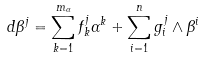<formula> <loc_0><loc_0><loc_500><loc_500>d \beta ^ { j } = \sum ^ { m _ { \alpha } } _ { k = 1 } f _ { k } ^ { j } \alpha ^ { k } + \sum ^ { n } _ { i = 1 } g ^ { j } _ { i } \land \beta ^ { i }</formula> 